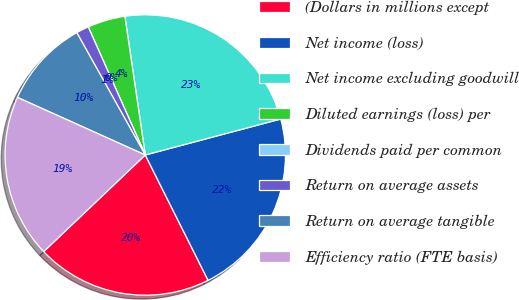<chart> <loc_0><loc_0><loc_500><loc_500><pie_chart><fcel>(Dollars in millions except<fcel>Net income (loss)<fcel>Net income excluding goodwill<fcel>Diluted earnings (loss) per<fcel>Dividends paid per common<fcel>Return on average assets<fcel>Return on average tangible<fcel>Efficiency ratio (FTE basis)<nl><fcel>20.29%<fcel>21.74%<fcel>23.19%<fcel>4.35%<fcel>0.0%<fcel>1.45%<fcel>10.14%<fcel>18.84%<nl></chart> 